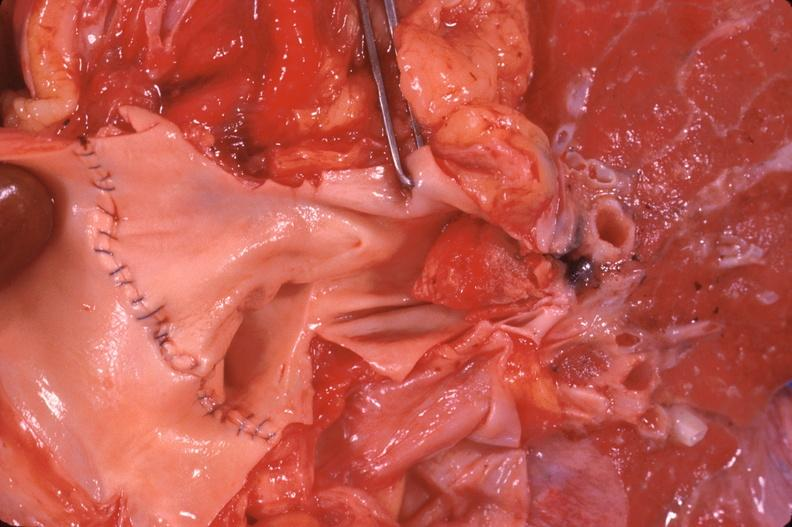what does this image show?
Answer the question using a single word or phrase. Thromboembolus from leg veins in pulmonary artery 